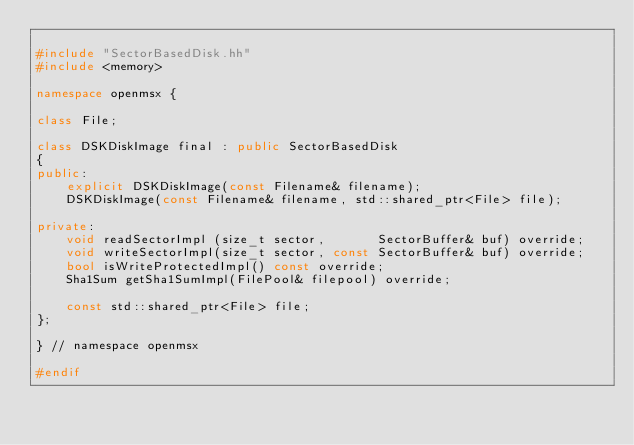Convert code to text. <code><loc_0><loc_0><loc_500><loc_500><_C++_>
#include "SectorBasedDisk.hh"
#include <memory>

namespace openmsx {

class File;

class DSKDiskImage final : public SectorBasedDisk
{
public:
	explicit DSKDiskImage(const Filename& filename);
	DSKDiskImage(const Filename& filename, std::shared_ptr<File> file);

private:
	void readSectorImpl (size_t sector,       SectorBuffer& buf) override;
	void writeSectorImpl(size_t sector, const SectorBuffer& buf) override;
	bool isWriteProtectedImpl() const override;
	Sha1Sum getSha1SumImpl(FilePool& filepool) override;

	const std::shared_ptr<File> file;
};

} // namespace openmsx

#endif
</code> 